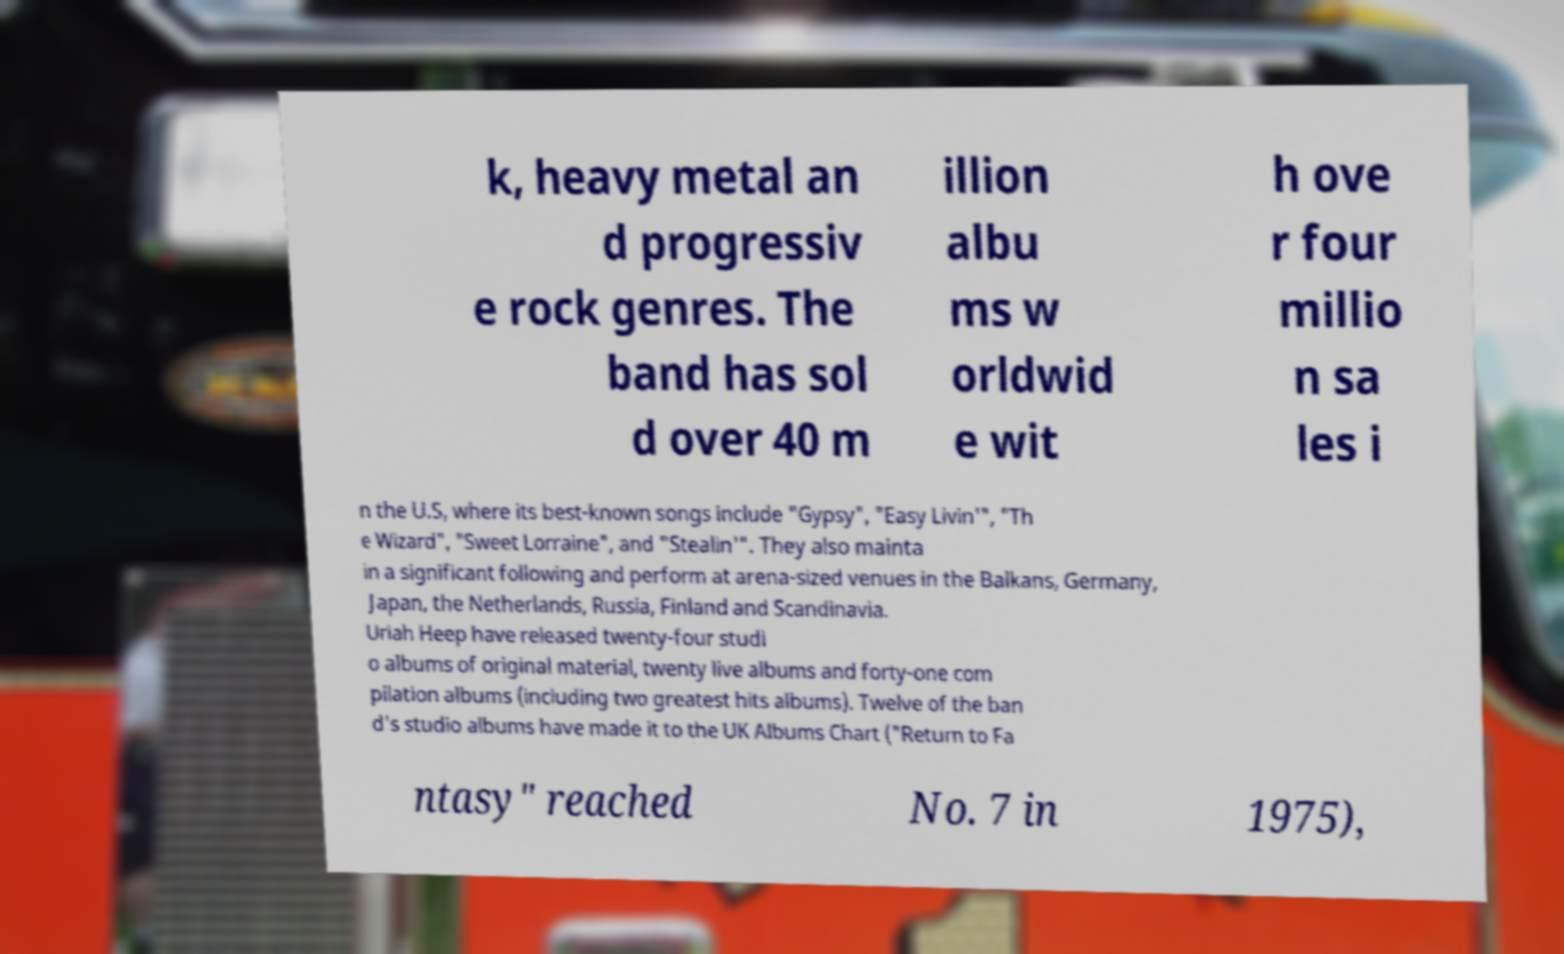Please identify and transcribe the text found in this image. k, heavy metal an d progressiv e rock genres. The band has sol d over 40 m illion albu ms w orldwid e wit h ove r four millio n sa les i n the U.S, where its best-known songs include "Gypsy", "Easy Livin'", "Th e Wizard", "Sweet Lorraine", and "Stealin'". They also mainta in a significant following and perform at arena-sized venues in the Balkans, Germany, Japan, the Netherlands, Russia, Finland and Scandinavia. Uriah Heep have released twenty-four studi o albums of original material, twenty live albums and forty-one com pilation albums (including two greatest hits albums). Twelve of the ban d's studio albums have made it to the UK Albums Chart ("Return to Fa ntasy" reached No. 7 in 1975), 